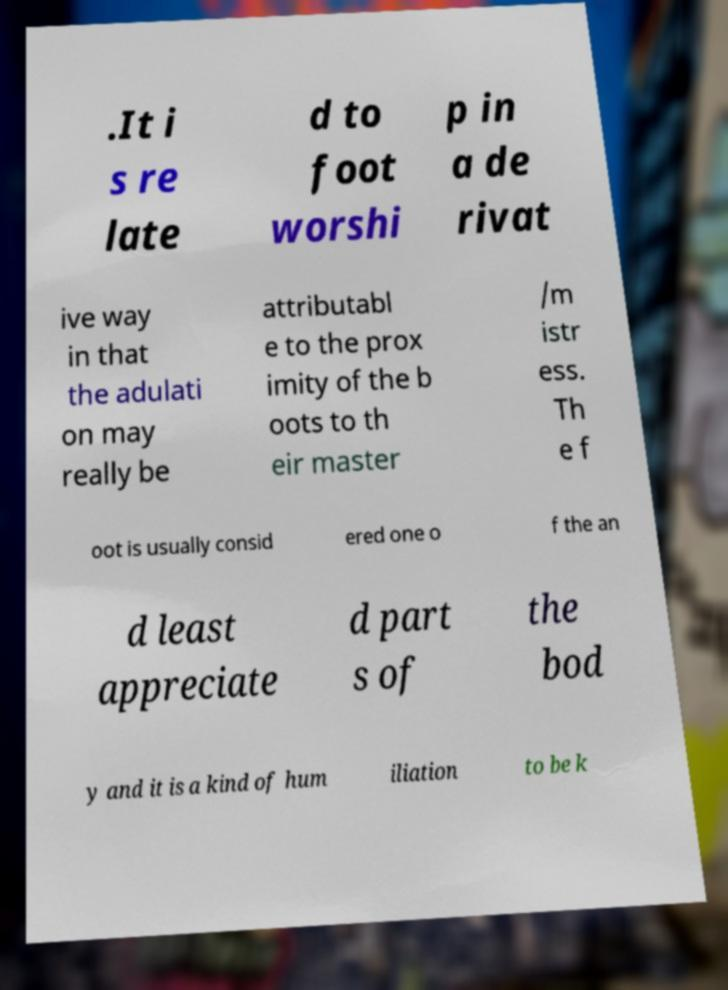I need the written content from this picture converted into text. Can you do that? .It i s re late d to foot worshi p in a de rivat ive way in that the adulati on may really be attributabl e to the prox imity of the b oots to th eir master /m istr ess. Th e f oot is usually consid ered one o f the an d least appreciate d part s of the bod y and it is a kind of hum iliation to be k 